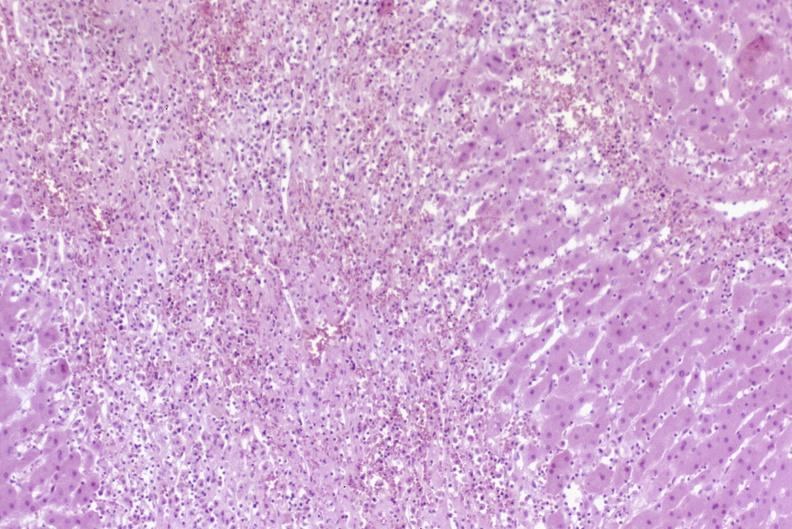what does this image show?
Answer the question using a single word or phrase. Severe acute rejection 